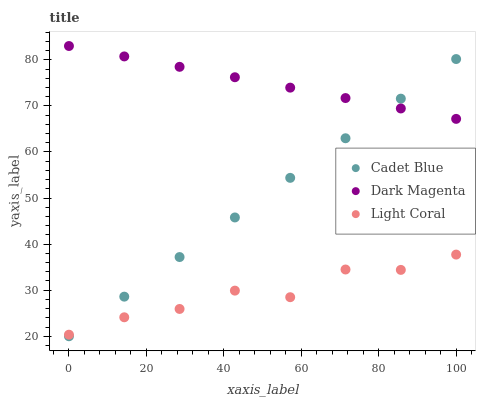Does Light Coral have the minimum area under the curve?
Answer yes or no. Yes. Does Dark Magenta have the maximum area under the curve?
Answer yes or no. Yes. Does Cadet Blue have the minimum area under the curve?
Answer yes or no. No. Does Cadet Blue have the maximum area under the curve?
Answer yes or no. No. Is Cadet Blue the smoothest?
Answer yes or no. Yes. Is Light Coral the roughest?
Answer yes or no. Yes. Is Dark Magenta the smoothest?
Answer yes or no. No. Is Dark Magenta the roughest?
Answer yes or no. No. Does Cadet Blue have the lowest value?
Answer yes or no. Yes. Does Dark Magenta have the lowest value?
Answer yes or no. No. Does Dark Magenta have the highest value?
Answer yes or no. Yes. Does Cadet Blue have the highest value?
Answer yes or no. No. Is Light Coral less than Dark Magenta?
Answer yes or no. Yes. Is Dark Magenta greater than Light Coral?
Answer yes or no. Yes. Does Dark Magenta intersect Cadet Blue?
Answer yes or no. Yes. Is Dark Magenta less than Cadet Blue?
Answer yes or no. No. Is Dark Magenta greater than Cadet Blue?
Answer yes or no. No. Does Light Coral intersect Dark Magenta?
Answer yes or no. No. 